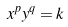<formula> <loc_0><loc_0><loc_500><loc_500>x ^ { p } y ^ { q } = k</formula> 